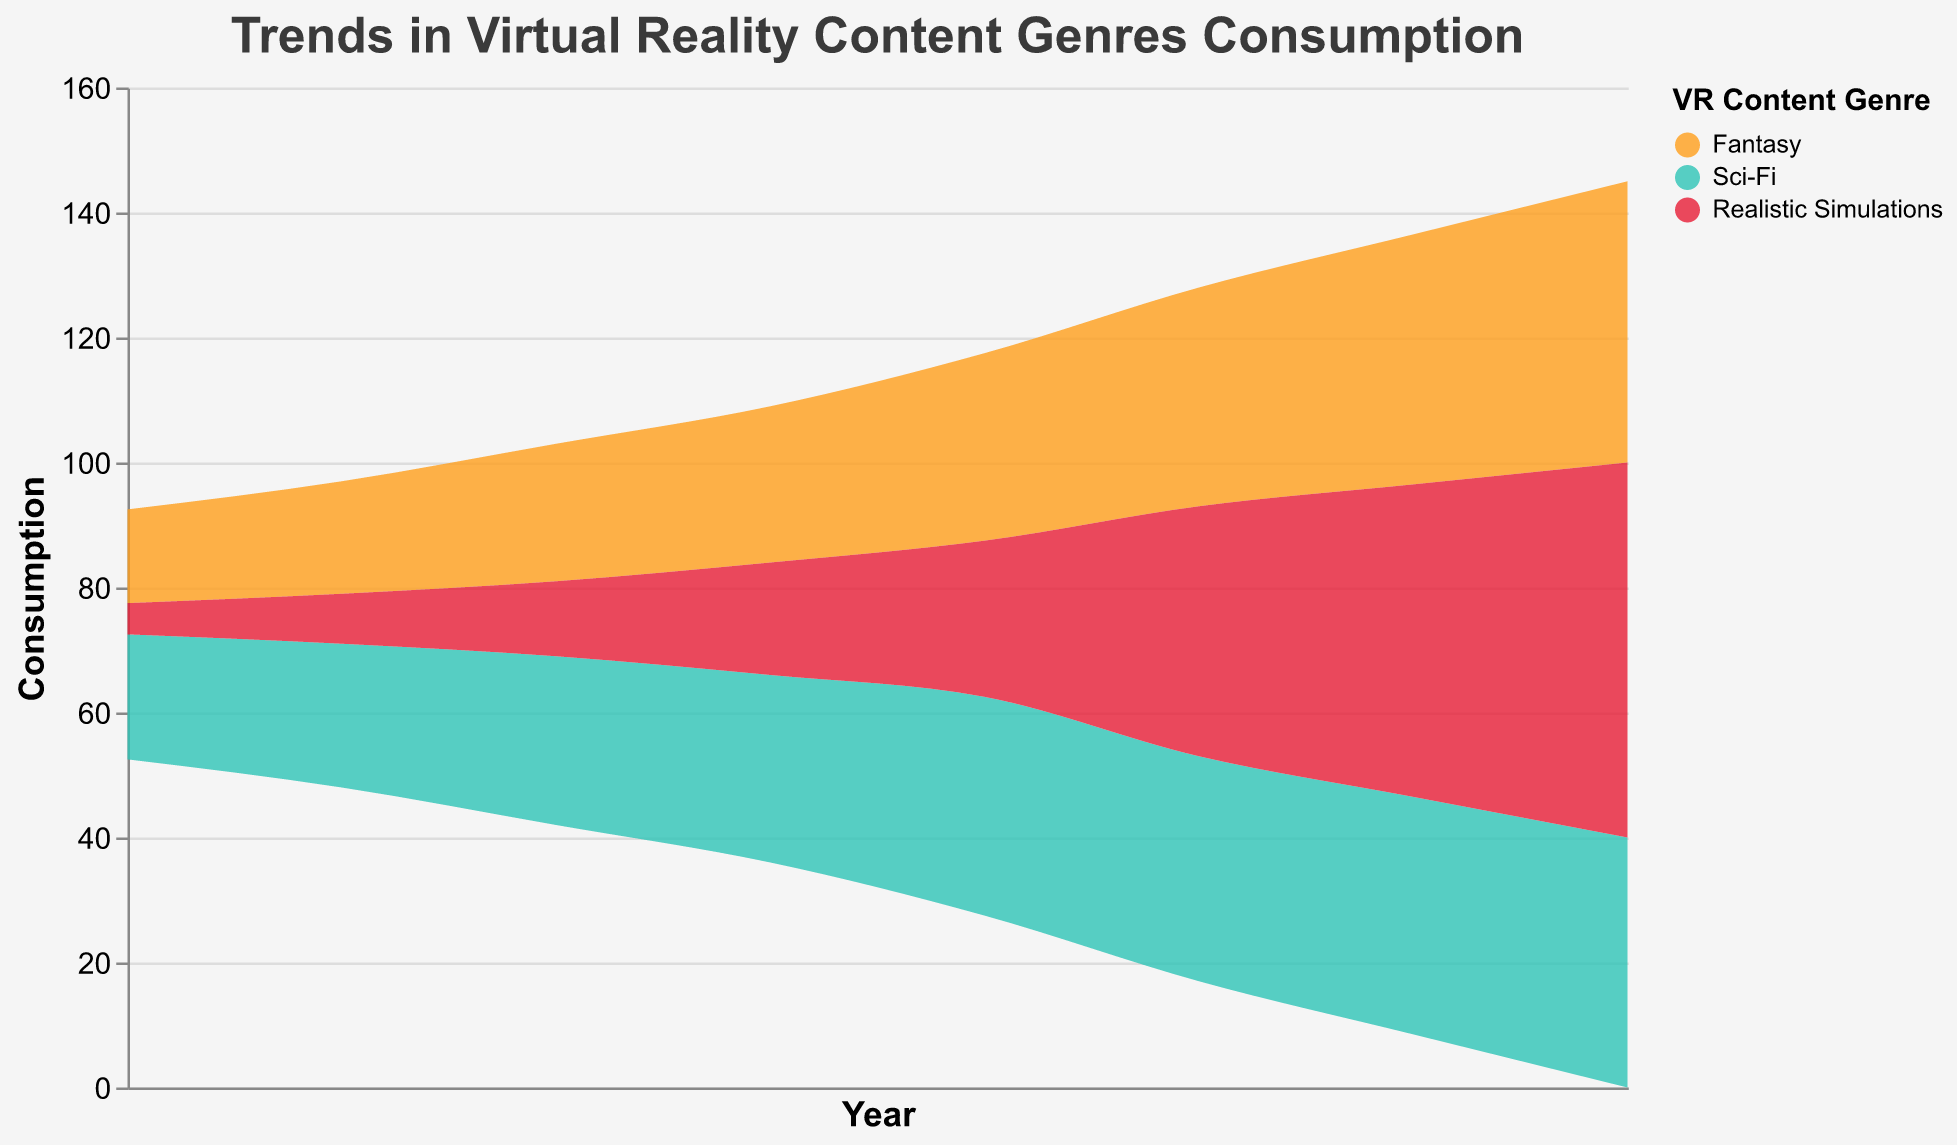What's the trend for Fantasy consumption over the years? Fantasy consumption shows a steadily increasing trend from 15 in 2015 to 45 in 2022.
Answer: Steadily increasing Between which years did Realistic Simulations see the most significant growth? The growth for Realistic Simulations was the most significant between 2019 and 2020, where it increased from 25 to 40, a change of 15 units.
Answer: 2019 to 2020 How does the consumption of Sci-Fi in 2022 compare to Fantasy in the same year? In 2022, Sci-Fi consumption is 40, while Fantasy consumption is 45. Fantasy consumption is higher than Sci-Fi in 2022.
Answer: Fantasy is higher than Sci-Fi Which genre had the highest consumption in 2020? Realistic Simulations had the highest consumption in 2020 with 40 units.
Answer: Realistic Simulations What is the average consumption for Realistic Simulations over the entire period? Sum the values of Realistic Simulations for all years (5+8+12+18+25+40+50+60) which equals 218, then divide by the number of years (8), resulting in an average of 27.25 units.
Answer: 27.25 What is the total consumption of all genres in 2019? The total consumption in 2019 is the sum of Fantasy, Sci-Fi, and Realistic Simulations which is 30 + 35 + 25 = 90 units.
Answer: 90 During which year(s) did Fantasy consumption equal Sci-Fi consumption? There are no years where Fantasy consumption equals Sci-Fi consumption; the values are different for each year.
Answer: None What's the difference between the highest and lowest consumption values for Fantasy? The highest consumption value for Fantasy is 45 in 2022 and the lowest is 15 in 2015. The difference is 45 - 15 = 30 units.
Answer: 30 Analyzing the whole period, which genre shows the most consistent growth pattern? Fantasy shows the most consistent growth pattern, increasing steadily each year without any drops.
Answer: Fantasy 